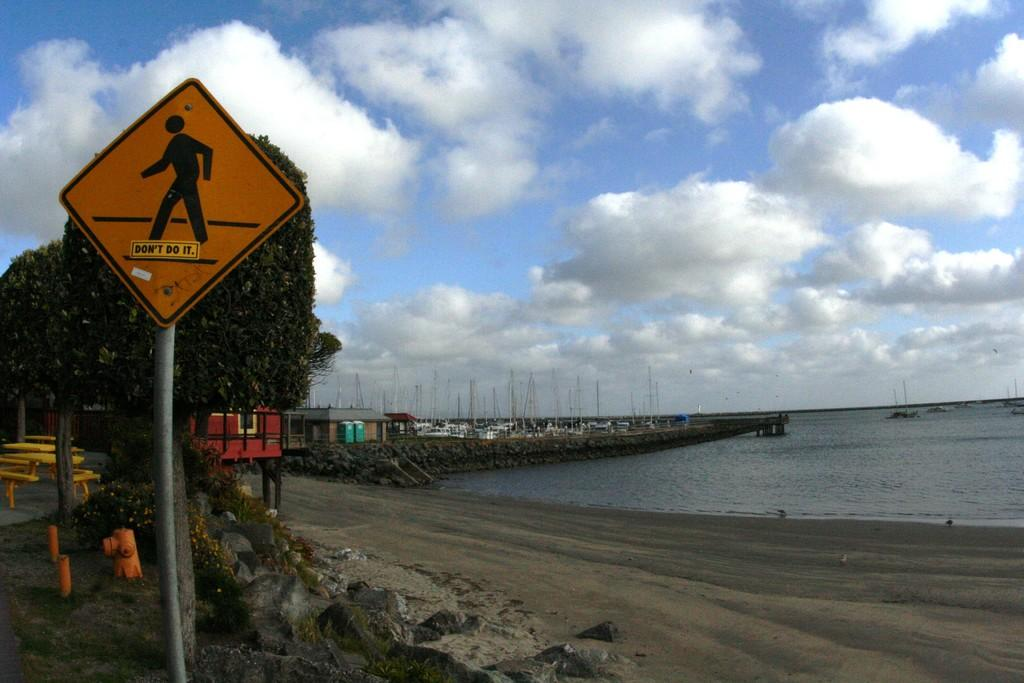<image>
Offer a succinct explanation of the picture presented. Someone has added a sticker to a pedestrian crossing sign that says "don't do it." 